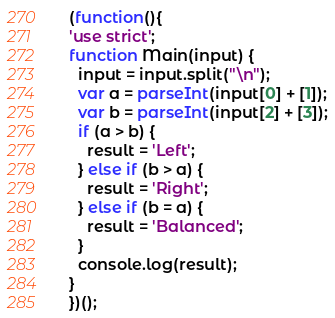Convert code to text. <code><loc_0><loc_0><loc_500><loc_500><_JavaScript_>(function(){
'use strict';
function Main(input) {
  input = input.split("\n");
  var a = parseInt(input[0] + [1]);
  var b = parseInt(input[2] + [3]);
  if (a > b) {
    result = 'Left';
  } else if (b > a) {
    result = 'Right';
  } else if (b = a) {
    result = 'Balanced';
  }
  console.log(result);
}
})();</code> 